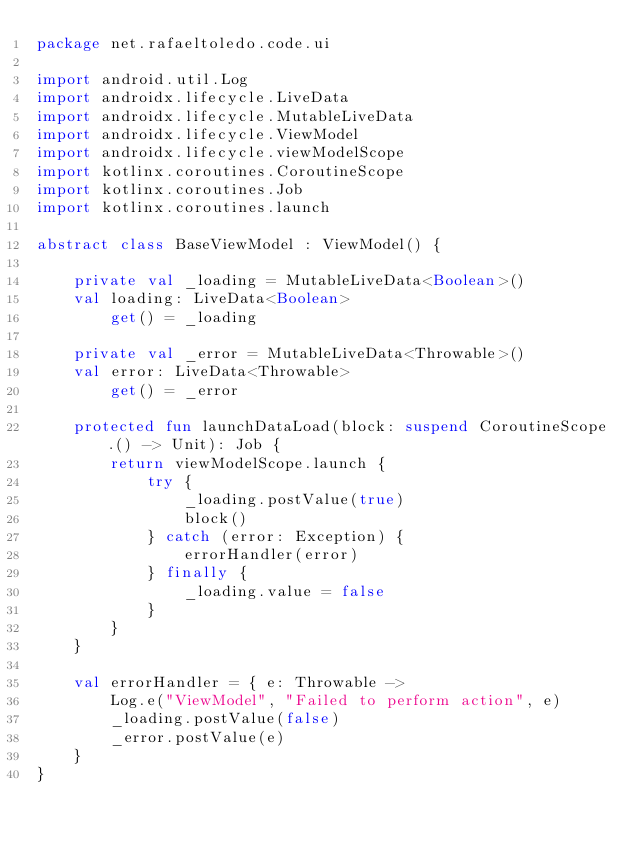Convert code to text. <code><loc_0><loc_0><loc_500><loc_500><_Kotlin_>package net.rafaeltoledo.code.ui

import android.util.Log
import androidx.lifecycle.LiveData
import androidx.lifecycle.MutableLiveData
import androidx.lifecycle.ViewModel
import androidx.lifecycle.viewModelScope
import kotlinx.coroutines.CoroutineScope
import kotlinx.coroutines.Job
import kotlinx.coroutines.launch

abstract class BaseViewModel : ViewModel() {

    private val _loading = MutableLiveData<Boolean>()
    val loading: LiveData<Boolean>
        get() = _loading

    private val _error = MutableLiveData<Throwable>()
    val error: LiveData<Throwable>
        get() = _error

    protected fun launchDataLoad(block: suspend CoroutineScope.() -> Unit): Job {
        return viewModelScope.launch {
            try {
                _loading.postValue(true)
                block()
            } catch (error: Exception) {
                errorHandler(error)
            } finally {
                _loading.value = false
            }
        }
    }

    val errorHandler = { e: Throwable ->
        Log.e("ViewModel", "Failed to perform action", e)
        _loading.postValue(false)
        _error.postValue(e)
    }
}</code> 